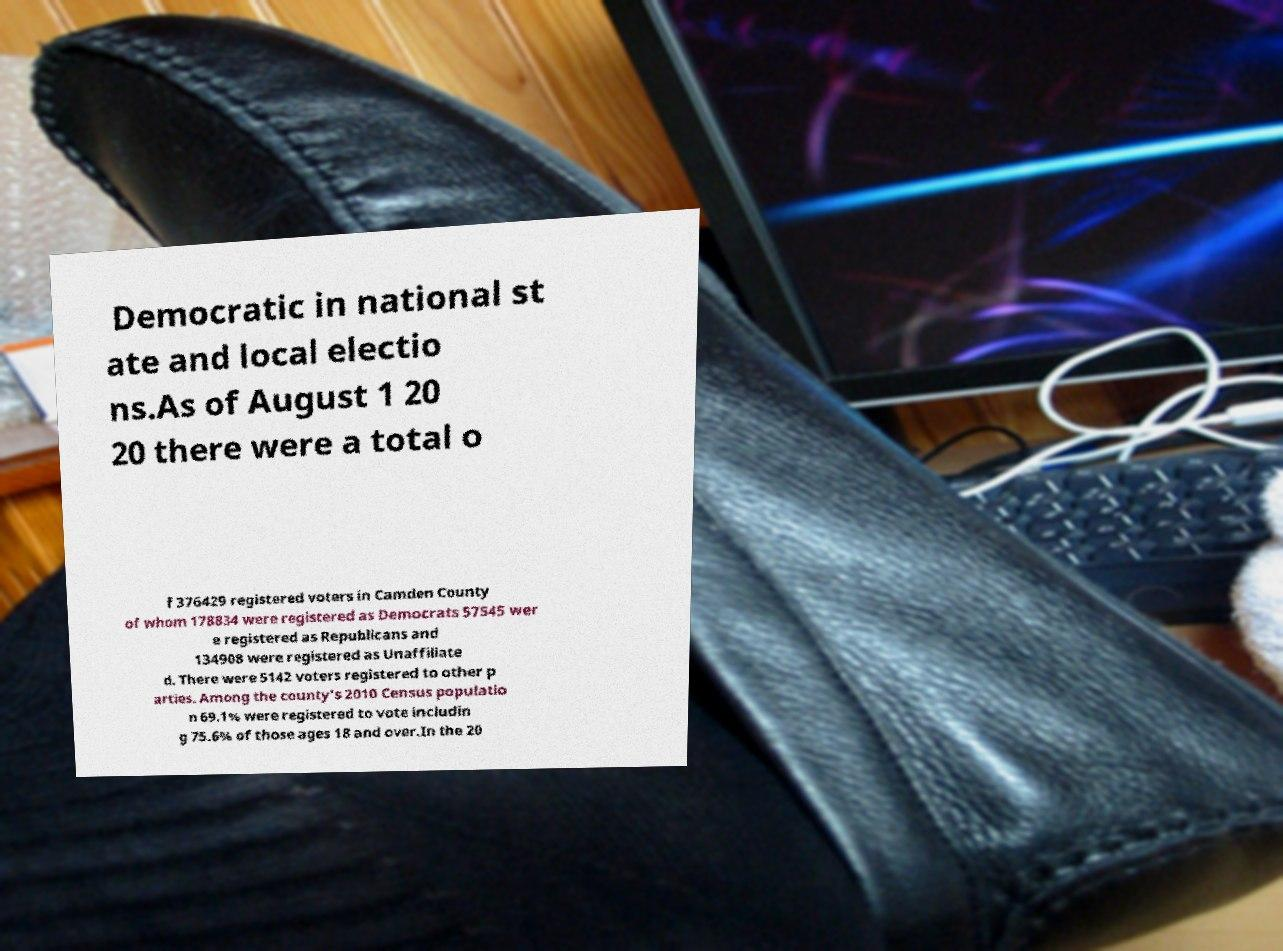Please identify and transcribe the text found in this image. Democratic in national st ate and local electio ns.As of August 1 20 20 there were a total o f 376429 registered voters in Camden County of whom 178834 were registered as Democrats 57545 wer e registered as Republicans and 134908 were registered as Unaffiliate d. There were 5142 voters registered to other p arties. Among the county's 2010 Census populatio n 69.1% were registered to vote includin g 75.6% of those ages 18 and over.In the 20 